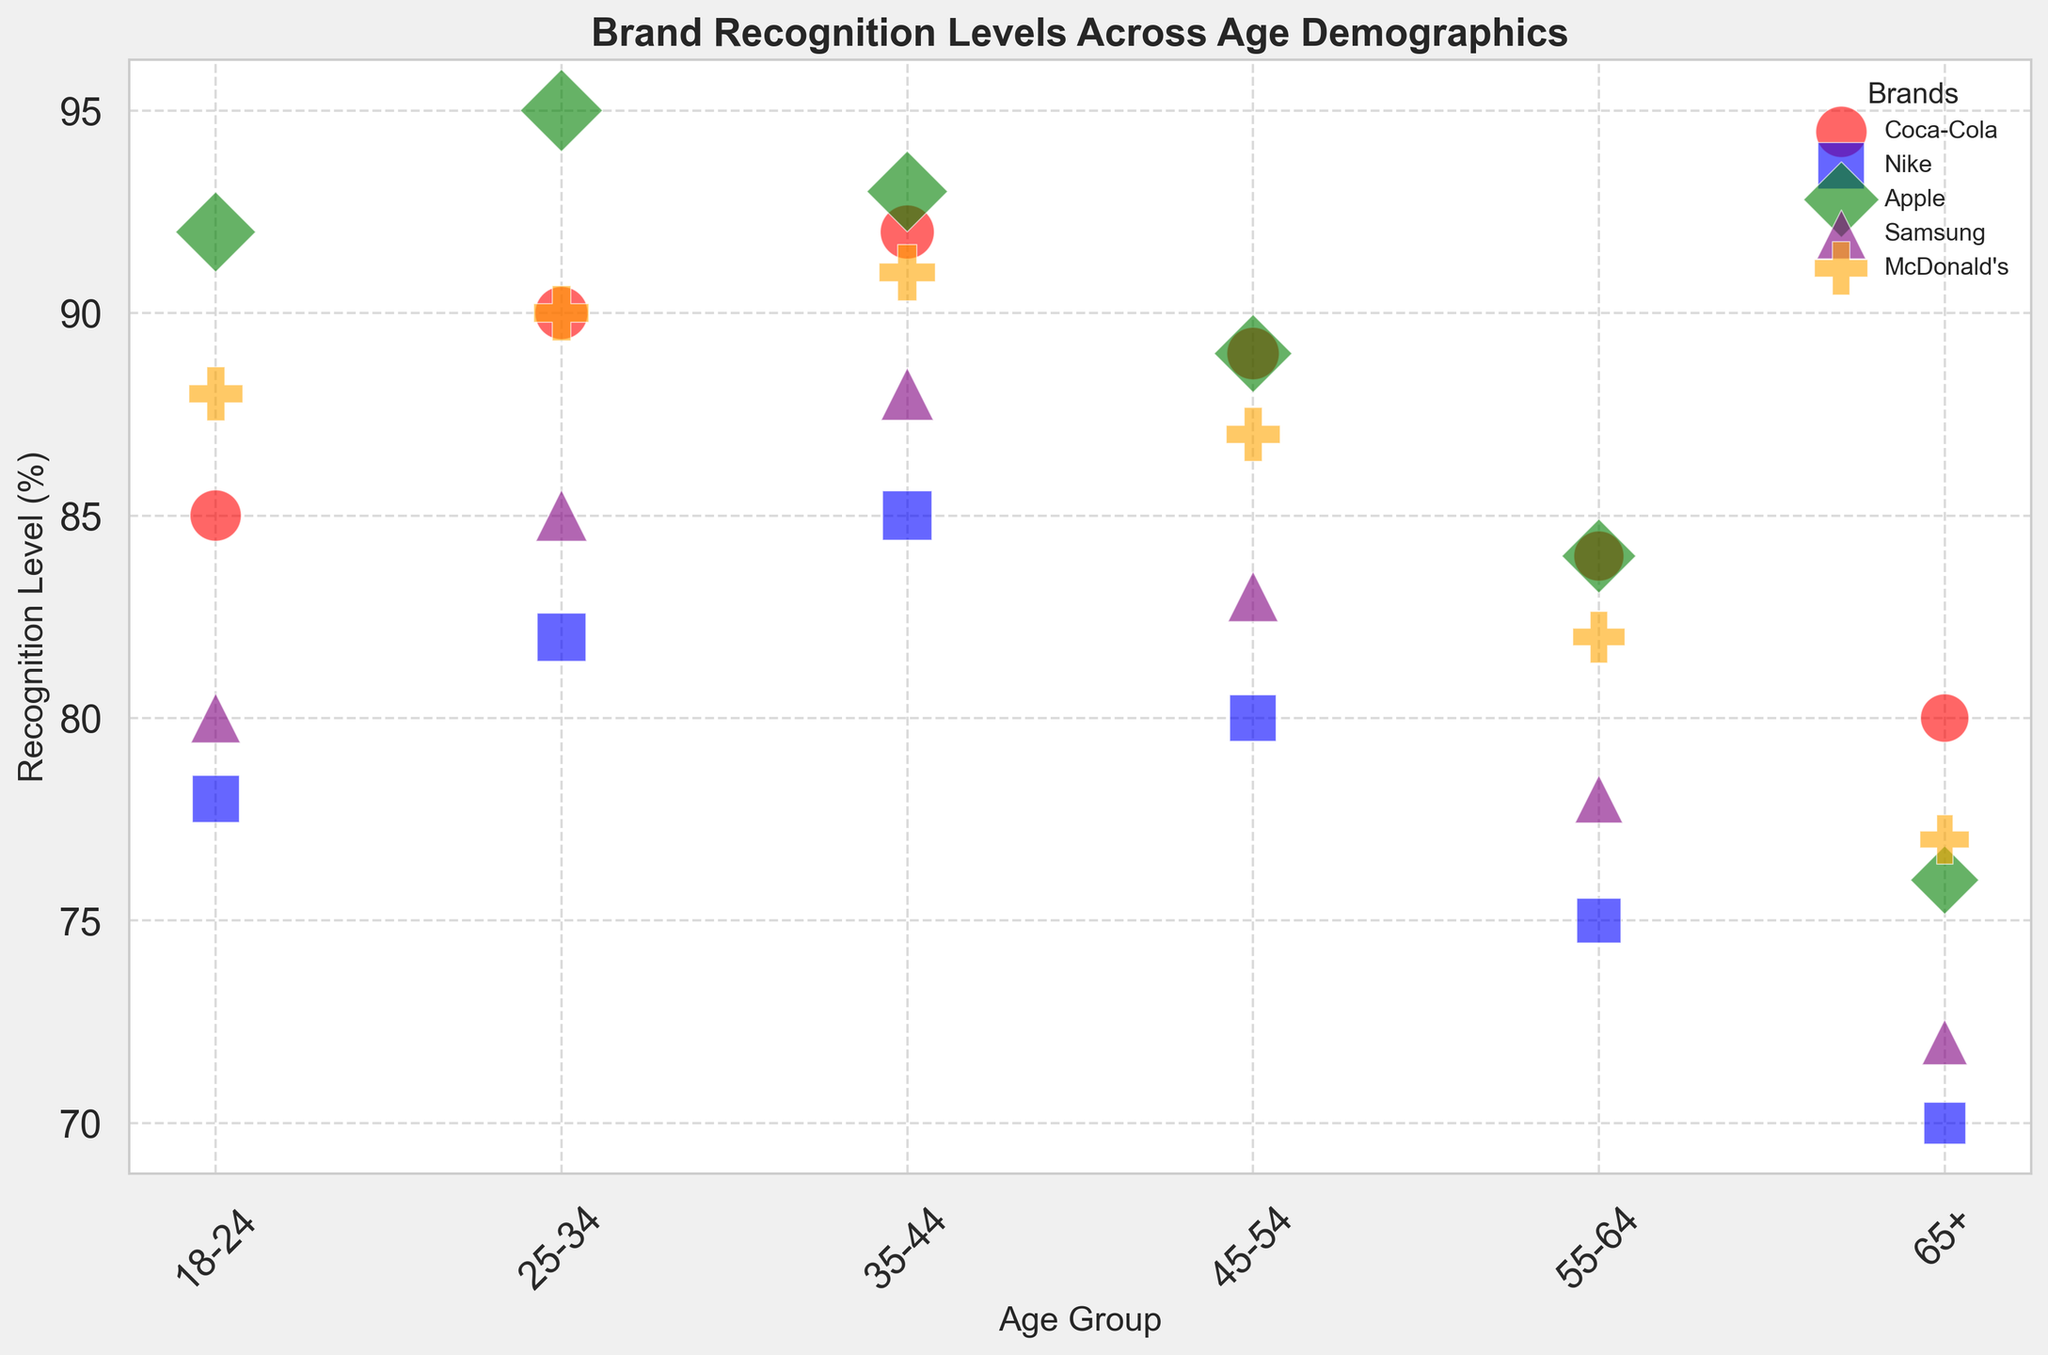Which age group has the highest brand recognition level for Apple? To find the age group with the highest brand recognition level for Apple, look at the green bubbles representing Apple. The highest point among the green bubbles represents the age group with the highest recognition level. For Apple, the age group 25-34 has the highest recognition level.
Answer: 25-34 Which brand has the smallest bubble size in the 18-24 age group? Examine the bubbles in the 18-24 age group and compare their sizes. The smallest bubble indicates the brand with the smallest market share. For the 18-24 age group, Nike has the smallest bubble size.
Answer: Nike What is the difference in recognition levels between the 18-24 and 45-54 age groups for Coca-Cola? Find the recognition levels of Coca-Cola in the 18-24 and 45-54 age groups, which are 85 and 89 respectively. Subtract the recognition level of the 18-24 age group from that of the 45-54 age group: 89 - 85.
Answer: 4 Which brand has the most consistent recognition levels across all age groups? To determine consistency, observe the shape of the data points for each brand. The brand having data points that show the least variation (i.e., the most stable/highly horizontal nature in the recognition levels) across age groups demonstrates the most consistency. Coca-Cola has relatively stable recognition levels across age groups.
Answer: Coca-Cola In which age group does Samsung have the highest recognition level, and how does it compare to Apple’s recognition level in the same age group? First, find the age group where Samsung has its highest recognition level, which is the 35-44 age group with a recognition level of 88. Then, identify Apple’s recognition level in that same age group, which is 93. So, Samsung's highest and Apple's recognition levels in that age group can be compared directly.
Answer: Samsung: 35-44 (88), Apple: 93 Which brand has the largest bubble size overall in the visual representation? Identify the brand with the largest market share by looking for the largest bubble. Apple, with the largest bubble size, indicating the highest market share.
Answer: Apple Between the age groups 18-24 and 65+, which brand shows the largest drop in recognition levels? Calculate the difference in recognition levels for each brand between the 18-24 and 65+ age groups. The largest drop across these computations points to the brand with the greatest decrease. For example, for Apple, the drop is 92 - 76 = 16, and similar calculations for other brands will show the largest drop belongs to Apple.
Answer: Apple How does the average recognition level for McDonald’s compare between the 25-34 age group and the 55-64 age group? Calculate the average recognition level for McDonald's in the specified age groups: (90+87)/2 for the 25-34 group and (82+77)/2 for the 55-64 group. Comparing these calculations will show the difference. For McDonald’s, it’s (90+91)/2 = 90.5 for the 25-34 age group and (82+77)/2 = 79.5 for the 55-64 group.
Answer: 25-34: 90.5, 55-64: 79.5 Which brands have a higher recognition level than Nike in the 35-44 age group? Identify Nike's recognition level for the 35-44 age group, which is 85. Then, compare it to other brands in the same age group. Both Apple (93) and McDonald's (91) have higher recognition levels.
Answer: Apple, McDonald’s 